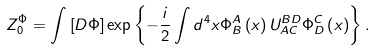<formula> <loc_0><loc_0><loc_500><loc_500>Z _ { 0 } ^ { \Phi } = \int \left [ D \Phi \right ] \exp \left \{ - \frac { i } { 2 } \int d ^ { 4 } x \Phi _ { B } ^ { A } \left ( x \right ) U _ { A C } ^ { B D } \Phi _ { D } ^ { C } \left ( x \right ) \right \} .</formula> 